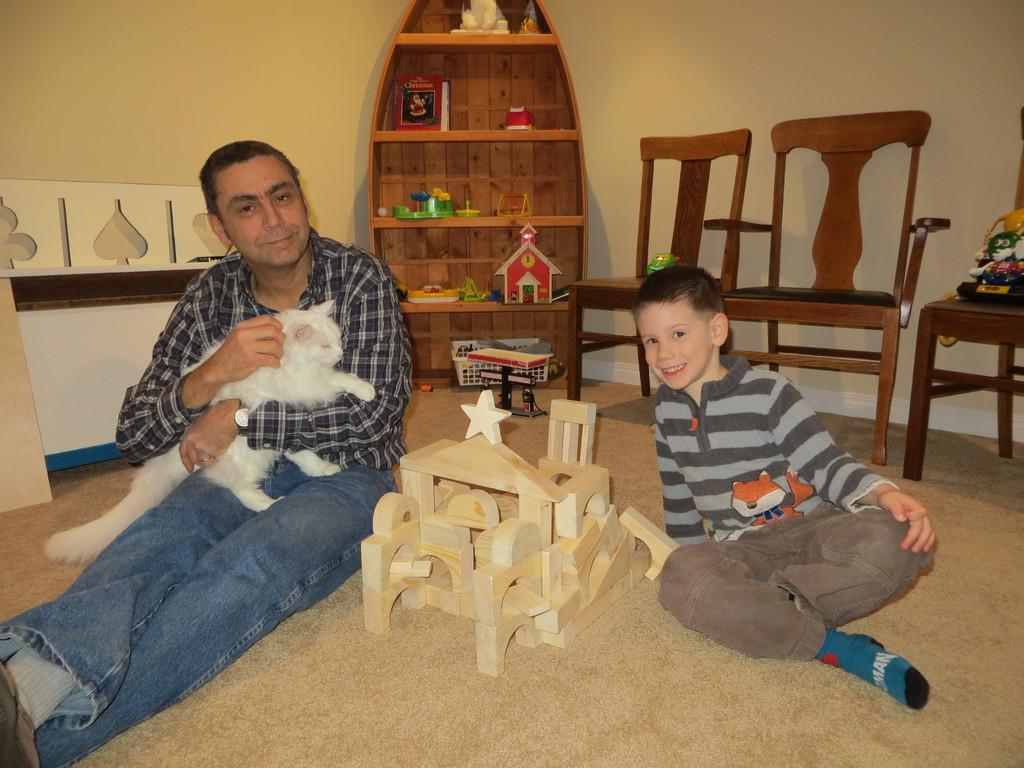How many people are sitting on the floor in the image? There are two persons sitting on the floor in the image. What are the expressions on the faces of the persons? The persons are smiling. What is one of the persons holding? One of the persons is holding a cat. What can be seen in the background of the image? There are chairs and a wall visible in the image. What year is depicted on the lock in the image? There is no lock present in the image, so it is not possible to determine the year depicted on it. 